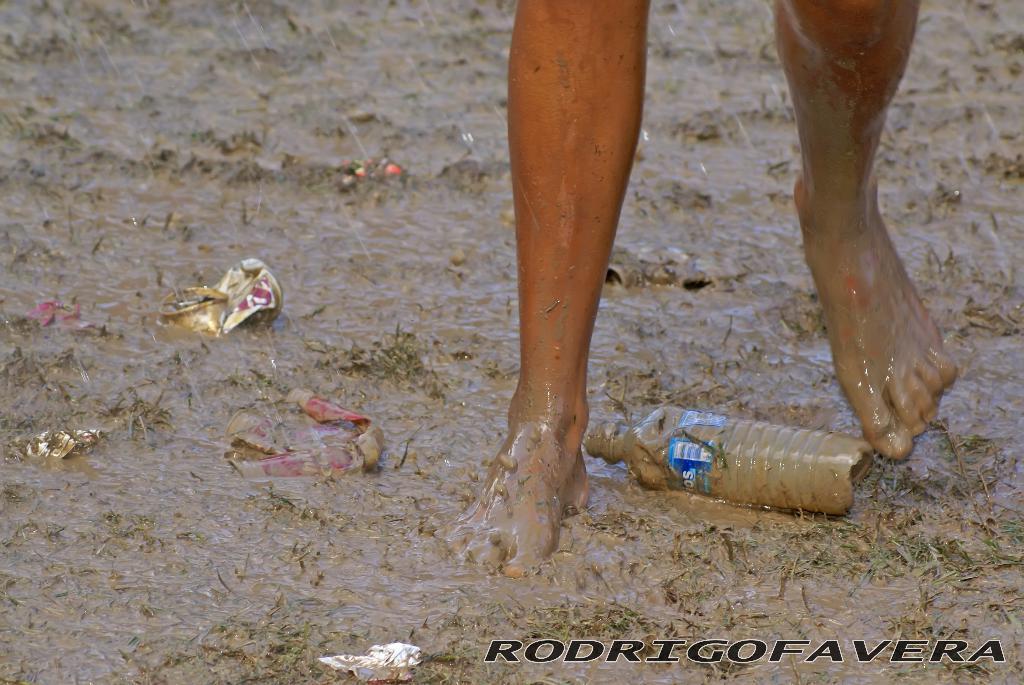Could you give a brief overview of what you see in this image? In this image, we can see person's legs and at the bottom, there are twins, a bottle and papers are on the mud water and there is some text. 